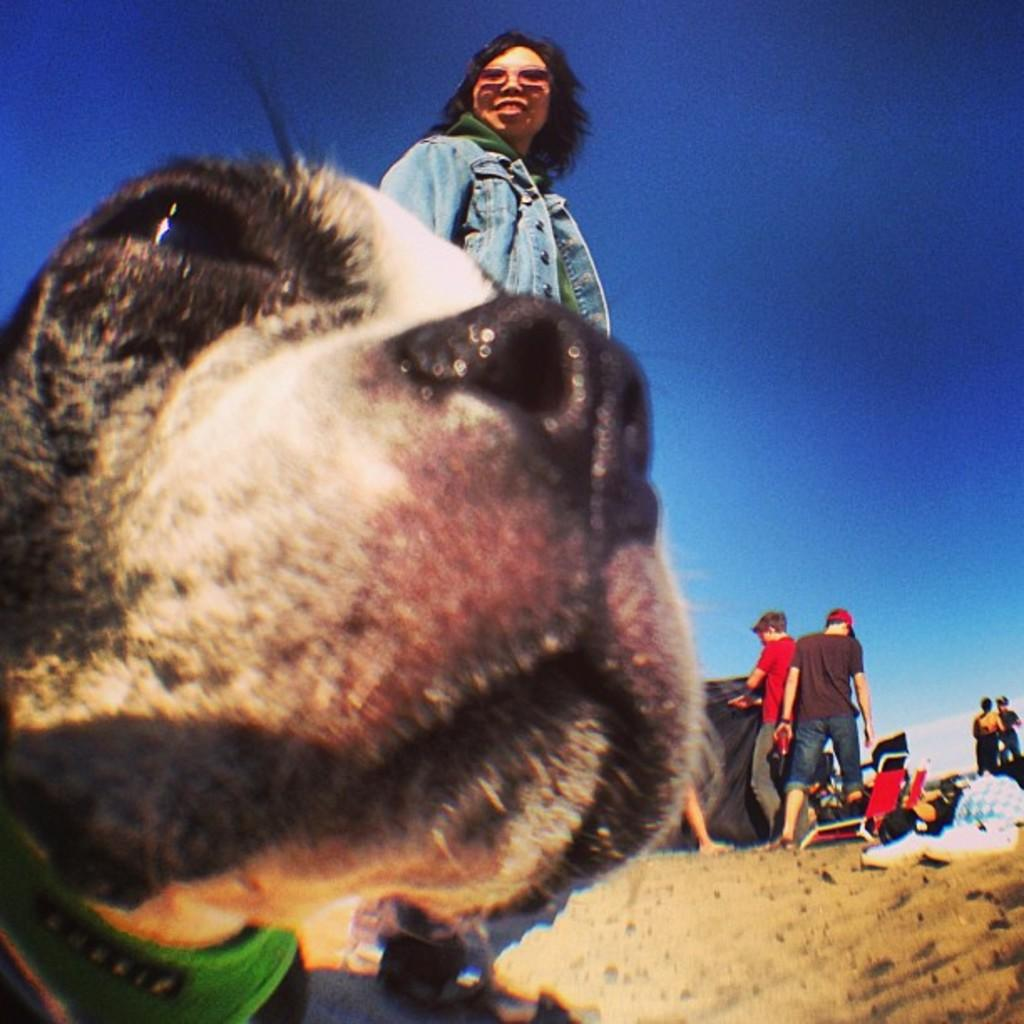What type of animal is in the image? There is an animal in the image, but the specific type cannot be determined from the provided facts. What else can be seen in the image besides the animal? There are people standing, sand, chairs, and objects beside the chairs visible in the image. What is the condition of the sky in the image? The sky is visible at the top of the image, and there are clouds in the sky. How does the zephyr affect the animal in the image? There is no mention of a zephyr in the image, so its effect on the animal cannot be determined. 